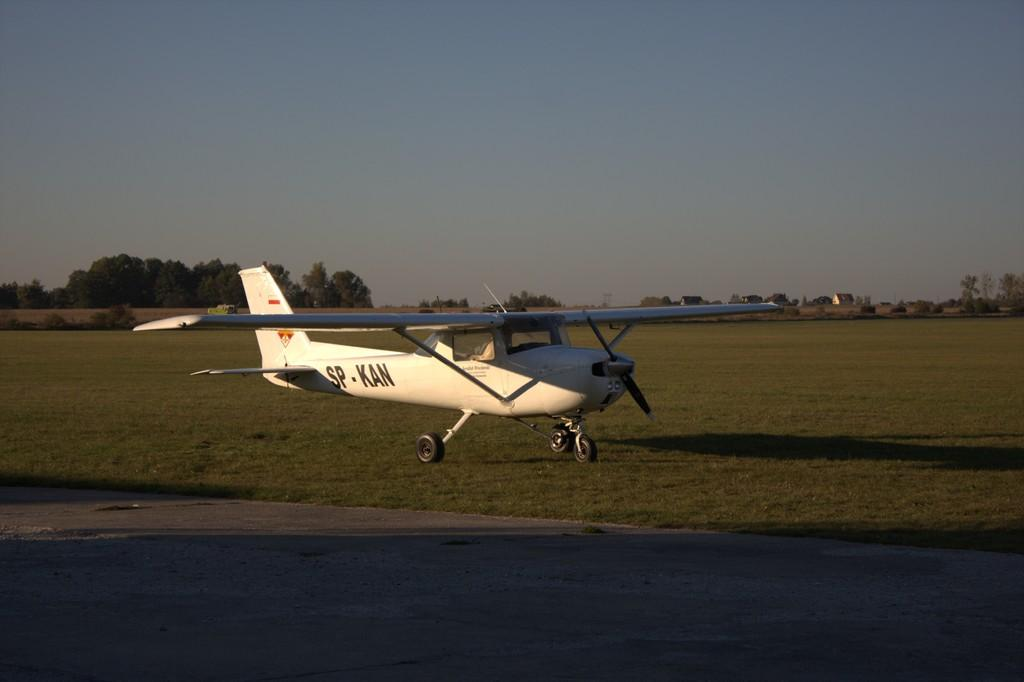<image>
Relay a brief, clear account of the picture shown. The word "SP-KAN" is painted on the side of the plane. 